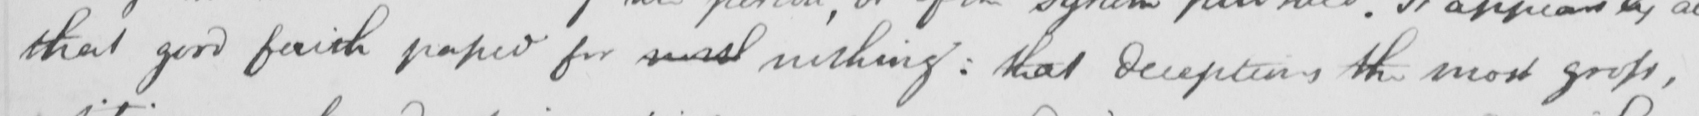Please provide the text content of this handwritten line. that good faith passed for small nothing :  that deceptions the most gross , 